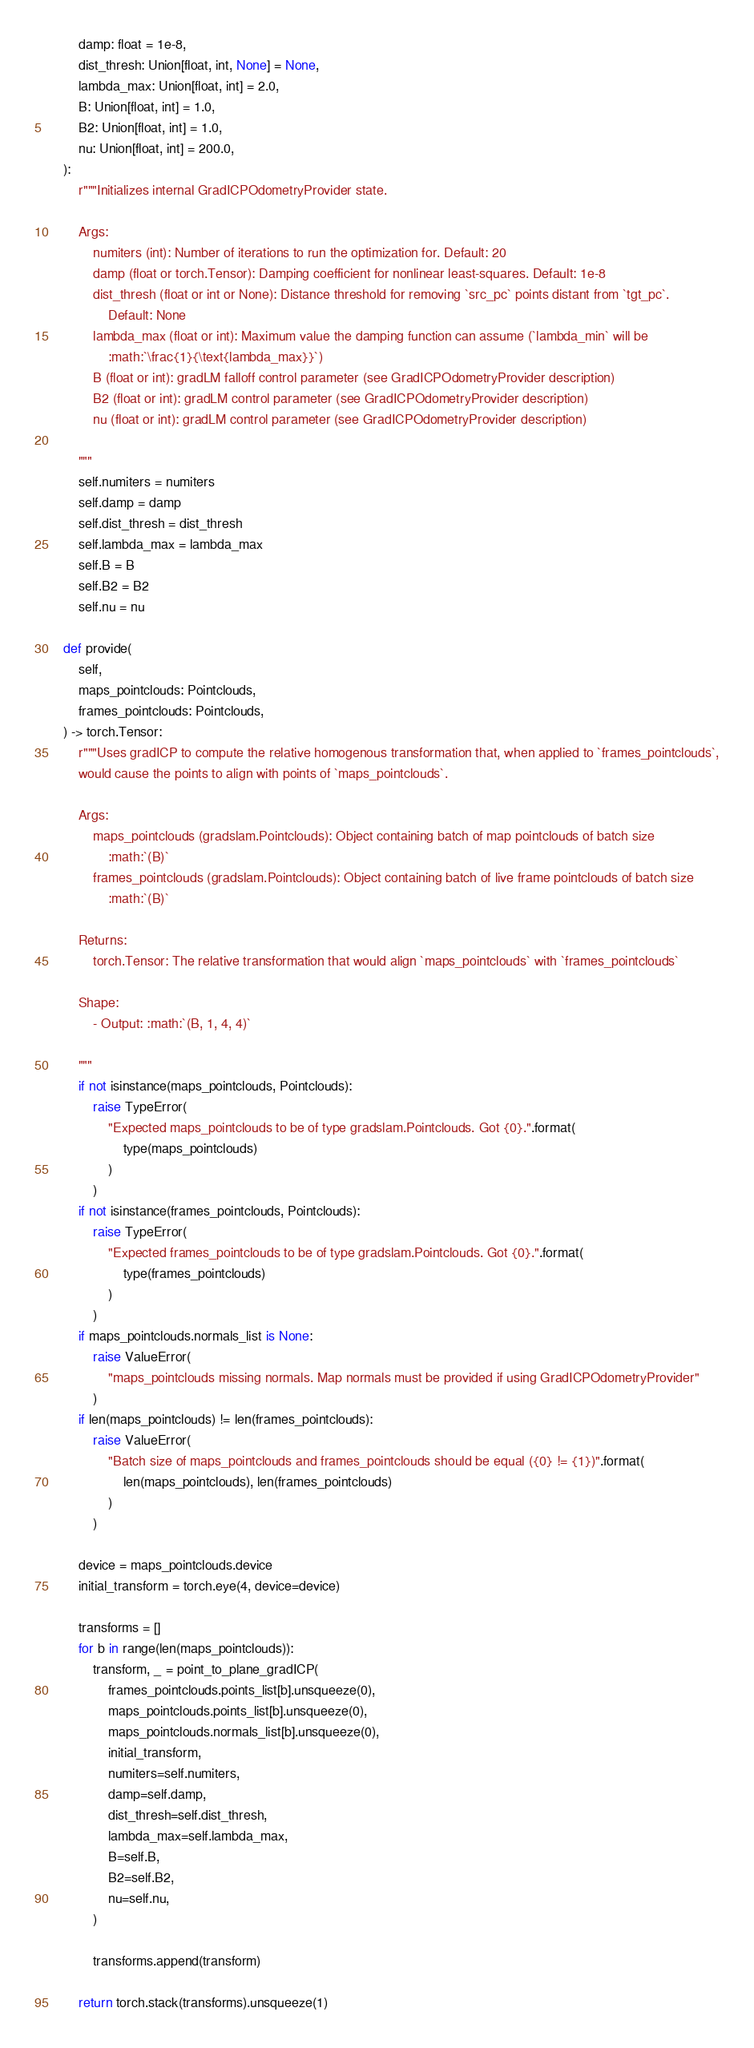<code> <loc_0><loc_0><loc_500><loc_500><_Python_>        damp: float = 1e-8,
        dist_thresh: Union[float, int, None] = None,
        lambda_max: Union[float, int] = 2.0,
        B: Union[float, int] = 1.0,
        B2: Union[float, int] = 1.0,
        nu: Union[float, int] = 200.0,
    ):
        r"""Initializes internal GradICPOdometryProvider state.

        Args:
            numiters (int): Number of iterations to run the optimization for. Default: 20
            damp (float or torch.Tensor): Damping coefficient for nonlinear least-squares. Default: 1e-8
            dist_thresh (float or int or None): Distance threshold for removing `src_pc` points distant from `tgt_pc`.
                Default: None
            lambda_max (float or int): Maximum value the damping function can assume (`lambda_min` will be
                :math:`\frac{1}{\text{lambda_max}}`)
            B (float or int): gradLM falloff control parameter (see GradICPOdometryProvider description)
            B2 (float or int): gradLM control parameter (see GradICPOdometryProvider description)
            nu (float or int): gradLM control parameter (see GradICPOdometryProvider description)

        """
        self.numiters = numiters
        self.damp = damp
        self.dist_thresh = dist_thresh
        self.lambda_max = lambda_max
        self.B = B
        self.B2 = B2
        self.nu = nu

    def provide(
        self,
        maps_pointclouds: Pointclouds,
        frames_pointclouds: Pointclouds,
    ) -> torch.Tensor:
        r"""Uses gradICP to compute the relative homogenous transformation that, when applied to `frames_pointclouds`,
        would cause the points to align with points of `maps_pointclouds`.

        Args:
            maps_pointclouds (gradslam.Pointclouds): Object containing batch of map pointclouds of batch size
                :math:`(B)`
            frames_pointclouds (gradslam.Pointclouds): Object containing batch of live frame pointclouds of batch size
                :math:`(B)`

        Returns:
            torch.Tensor: The relative transformation that would align `maps_pointclouds` with `frames_pointclouds`

        Shape:
            - Output: :math:`(B, 1, 4, 4)`

        """
        if not isinstance(maps_pointclouds, Pointclouds):
            raise TypeError(
                "Expected maps_pointclouds to be of type gradslam.Pointclouds. Got {0}.".format(
                    type(maps_pointclouds)
                )
            )
        if not isinstance(frames_pointclouds, Pointclouds):
            raise TypeError(
                "Expected frames_pointclouds to be of type gradslam.Pointclouds. Got {0}.".format(
                    type(frames_pointclouds)
                )
            )
        if maps_pointclouds.normals_list is None:
            raise ValueError(
                "maps_pointclouds missing normals. Map normals must be provided if using GradICPOdometryProvider"
            )
        if len(maps_pointclouds) != len(frames_pointclouds):
            raise ValueError(
                "Batch size of maps_pointclouds and frames_pointclouds should be equal ({0} != {1})".format(
                    len(maps_pointclouds), len(frames_pointclouds)
                )
            )

        device = maps_pointclouds.device
        initial_transform = torch.eye(4, device=device)

        transforms = []
        for b in range(len(maps_pointclouds)):
            transform, _ = point_to_plane_gradICP(
                frames_pointclouds.points_list[b].unsqueeze(0),
                maps_pointclouds.points_list[b].unsqueeze(0),
                maps_pointclouds.normals_list[b].unsqueeze(0),
                initial_transform,
                numiters=self.numiters,
                damp=self.damp,
                dist_thresh=self.dist_thresh,
                lambda_max=self.lambda_max,
                B=self.B,
                B2=self.B2,
                nu=self.nu,
            )

            transforms.append(transform)

        return torch.stack(transforms).unsqueeze(1)
</code> 